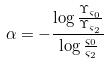Convert formula to latex. <formula><loc_0><loc_0><loc_500><loc_500>\alpha = - \frac { \log \frac { \Upsilon _ { \varsigma _ { 0 } } } { \Upsilon _ { \varsigma _ { 2 } } } } { \log \frac { \varsigma _ { 0 } } { \varsigma _ { 2 } } }</formula> 